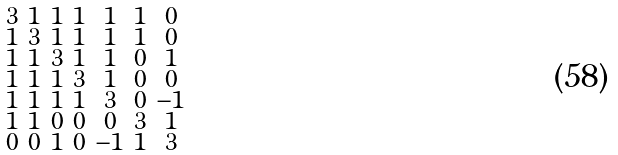<formula> <loc_0><loc_0><loc_500><loc_500>\begin{smallmatrix} 3 & 1 & 1 & 1 & 1 & 1 & 0 \\ 1 & 3 & 1 & 1 & 1 & 1 & 0 \\ 1 & 1 & 3 & 1 & 1 & 0 & 1 \\ 1 & 1 & 1 & 3 & 1 & 0 & 0 \\ 1 & 1 & 1 & 1 & 3 & 0 & - 1 \\ 1 & 1 & 0 & 0 & 0 & 3 & 1 \\ 0 & 0 & 1 & 0 & - 1 & 1 & 3 \end{smallmatrix}</formula> 